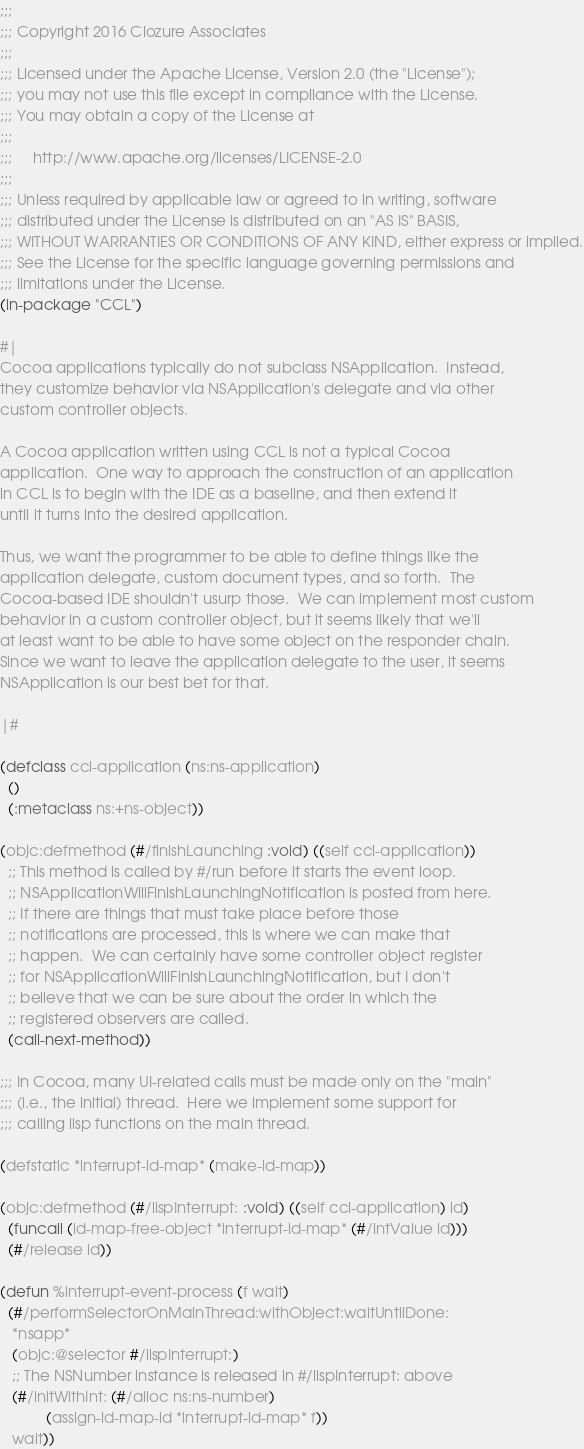Convert code to text. <code><loc_0><loc_0><loc_500><loc_500><_Lisp_>;;;
;;; Copyright 2016 Clozure Associates
;;;
;;; Licensed under the Apache License, Version 2.0 (the "License");
;;; you may not use this file except in compliance with the License.
;;; You may obtain a copy of the License at
;;;
;;;     http://www.apache.org/licenses/LICENSE-2.0
;;;
;;; Unless required by applicable law or agreed to in writing, software
;;; distributed under the License is distributed on an "AS IS" BASIS,
;;; WITHOUT WARRANTIES OR CONDITIONS OF ANY KIND, either express or implied.
;;; See the License for the specific language governing permissions and
;;; limitations under the License.
(in-package "CCL")

#|
Cocoa applications typically do not subclass NSApplication.  Instead,
they customize behavior via NSApplication's delegate and via other
custom controller objects.

A Cocoa application written using CCL is not a typical Cocoa
application.  One way to approach the construction of an application
in CCL is to begin with the IDE as a baseline, and then extend it
until it turns into the desired application.

Thus, we want the programmer to be able to define things like the
application delegate, custom document types, and so forth.  The
Cocoa-based IDE shouldn't usurp those.  We can implement most custom
behavior in a custom controller object, but it seems likely that we'll
at least want to be able to have some object on the responder chain.
Since we want to leave the application delegate to the user, it seems
NSApplication is our best bet for that.

|#

(defclass ccl-application (ns:ns-application)
  ()
  (:metaclass ns:+ns-object))

(objc:defmethod (#/finishLaunching :void) ((self ccl-application))
  ;; This method is called by #/run before it starts the event loop.
  ;; NSApplicationWillFinishLaunchingNotification is posted from here.
  ;; If there are things that must take place before those
  ;; notifications are processed, this is where we can make that
  ;; happen.  We can certainly have some controller object register
  ;; for NSApplicationWillFinishLaunchingNotification, but I don't
  ;; believe that we can be sure about the order in which the
  ;; registered observers are called.
  (call-next-method))

;;; In Cocoa, many UI-related calls must be made only on the "main"
;;; (i.e., the initial) thread.  Here we implement some support for
;;; calling lisp functions on the main thread.

(defstatic *interrupt-id-map* (make-id-map))

(objc:defmethod (#/lispInterrupt: :void) ((self ccl-application) id)
  (funcall (id-map-free-object *interrupt-id-map* (#/intValue id)))
  (#/release id))

(defun %interrupt-event-process (f wait)
  (#/performSelectorOnMainThread:withObject:waitUntilDone:
   *nsapp*
   (objc:@selector #/lispInterrupt:)
   ;; The NSNumber instance is released in #/lispInterrupt: above
   (#/initWithInt: (#/alloc ns:ns-number)
		   (assign-id-map-id *interrupt-id-map* f))
   wait))

</code> 